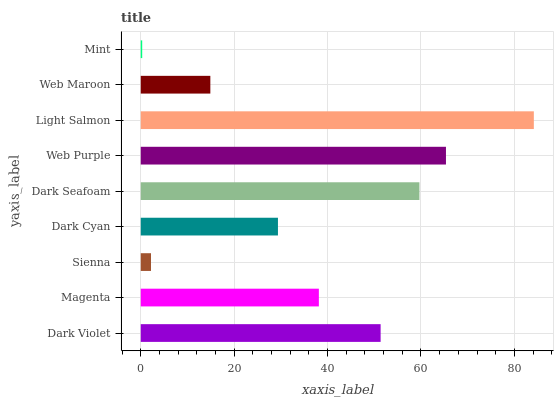Is Mint the minimum?
Answer yes or no. Yes. Is Light Salmon the maximum?
Answer yes or no. Yes. Is Magenta the minimum?
Answer yes or no. No. Is Magenta the maximum?
Answer yes or no. No. Is Dark Violet greater than Magenta?
Answer yes or no. Yes. Is Magenta less than Dark Violet?
Answer yes or no. Yes. Is Magenta greater than Dark Violet?
Answer yes or no. No. Is Dark Violet less than Magenta?
Answer yes or no. No. Is Magenta the high median?
Answer yes or no. Yes. Is Magenta the low median?
Answer yes or no. Yes. Is Light Salmon the high median?
Answer yes or no. No. Is Dark Violet the low median?
Answer yes or no. No. 